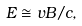<formula> <loc_0><loc_0><loc_500><loc_500>E \cong v B / c ,</formula> 